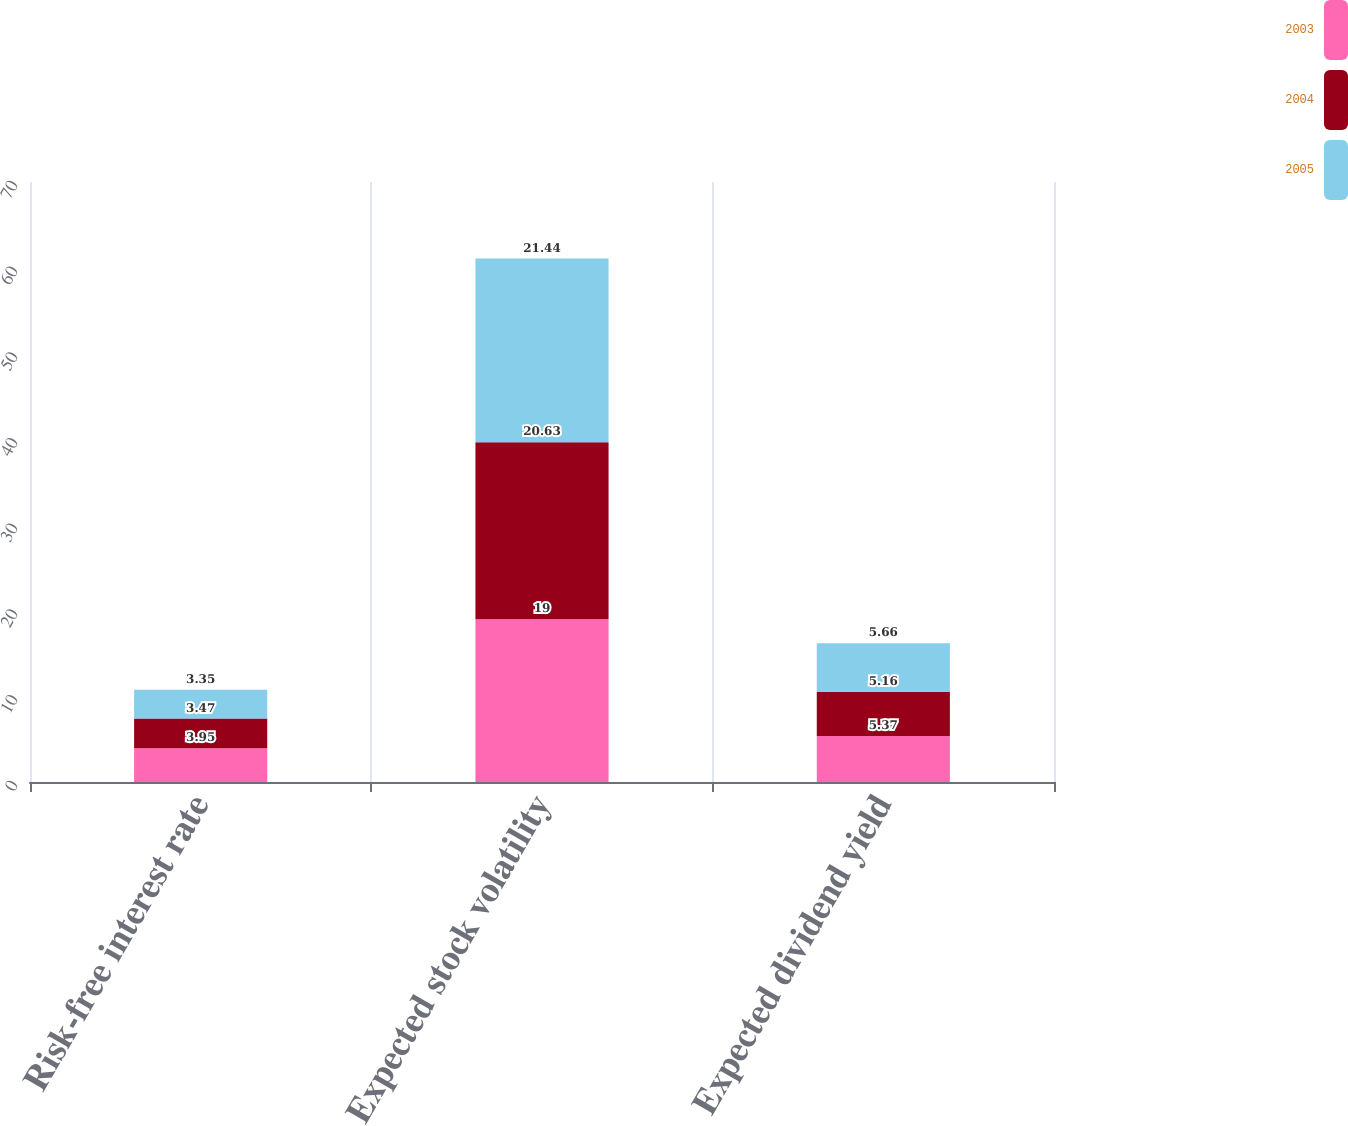Convert chart to OTSL. <chart><loc_0><loc_0><loc_500><loc_500><stacked_bar_chart><ecel><fcel>Risk-free interest rate<fcel>Expected stock volatility<fcel>Expected dividend yield<nl><fcel>2003<fcel>3.95<fcel>19<fcel>5.37<nl><fcel>2004<fcel>3.47<fcel>20.63<fcel>5.16<nl><fcel>2005<fcel>3.35<fcel>21.44<fcel>5.66<nl></chart> 